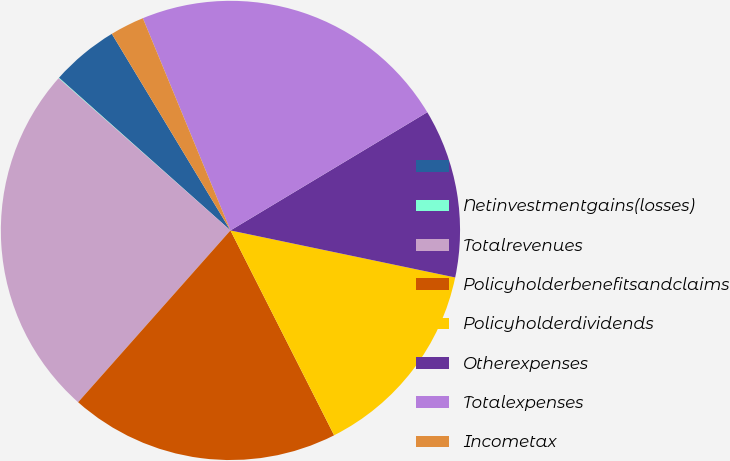Convert chart. <chart><loc_0><loc_0><loc_500><loc_500><pie_chart><ecel><fcel>Netinvestmentgains(losses)<fcel>Totalrevenues<fcel>Policyholderbenefitsandclaims<fcel>Policyholderdividends<fcel>Otherexpenses<fcel>Totalexpenses<fcel>Incometax<nl><fcel>4.78%<fcel>0.04%<fcel>24.99%<fcel>19.0%<fcel>14.26%<fcel>11.89%<fcel>22.62%<fcel>2.41%<nl></chart> 